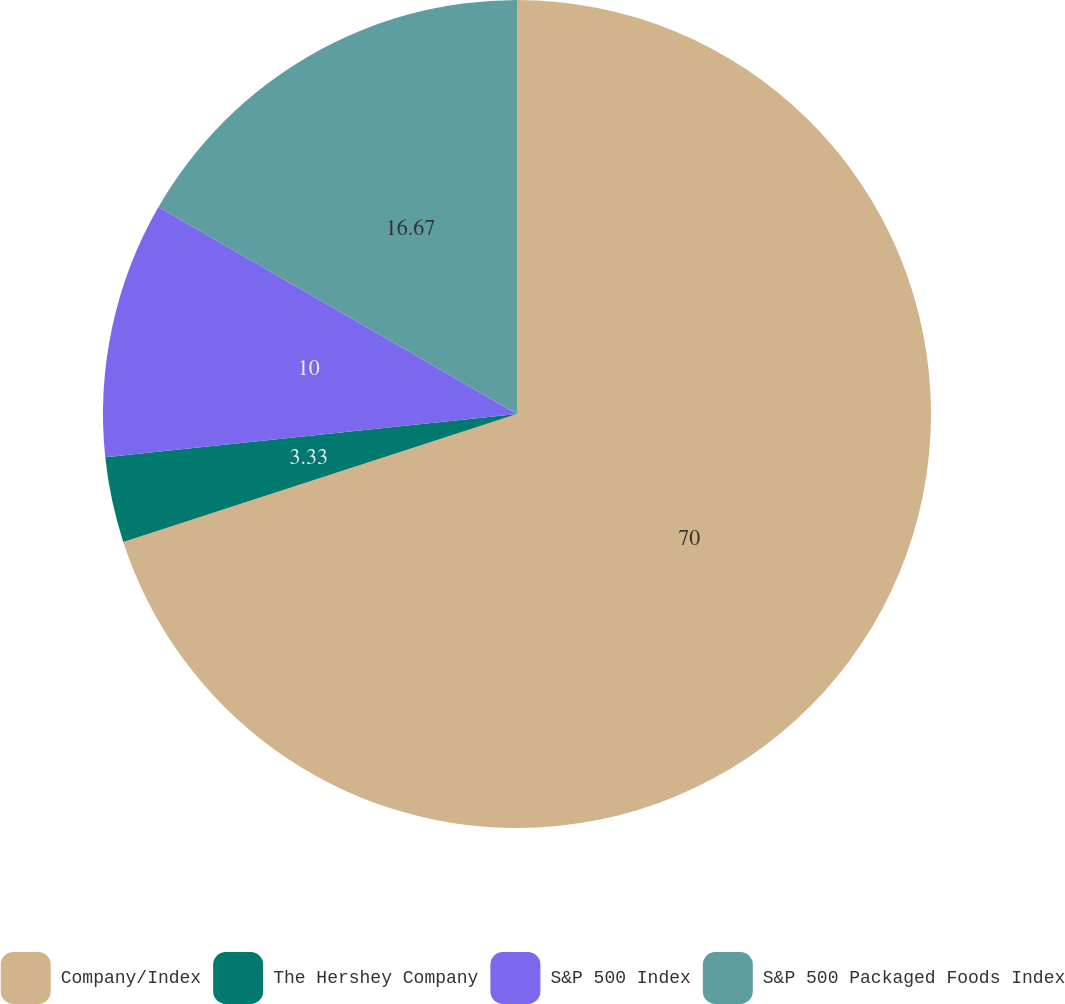Convert chart to OTSL. <chart><loc_0><loc_0><loc_500><loc_500><pie_chart><fcel>Company/Index<fcel>The Hershey Company<fcel>S&P 500 Index<fcel>S&P 500 Packaged Foods Index<nl><fcel>70.0%<fcel>3.33%<fcel>10.0%<fcel>16.67%<nl></chart> 